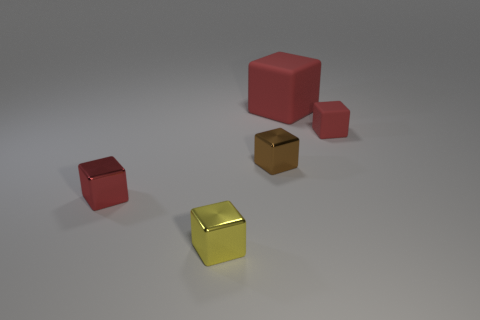Can you describe all the objects in this image, mentioning their colors and relative sizes? Certainly! There are four objects in total, featuring geometric shapes. Starting with the foreground, we have a small but vibrant yellow metal cube that has a high shine, suggesting it's possibly the smallest but most reflective object. Moving clockwise, there is a red cube of a substantial size, larger than any other individual object visible. Just behind it, there is another, smaller red cube, which based on perspective seems to be around half the size of the larger red cube. Farthest from view, partially obscured by the red objects, is a metallic block that has more volume than the tiny yellow cube but its precise size is somewhat ambiguous due to the angle. All objects exhibit a smooth surface and are placed against a neutral grey background for contrast. 